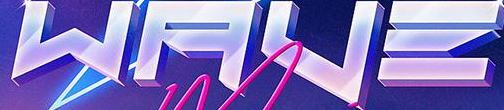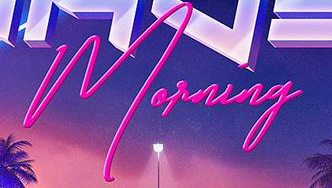Transcribe the words shown in these images in order, separated by a semicolon. WAVΞ; Morning 